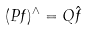Convert formula to latex. <formula><loc_0><loc_0><loc_500><loc_500>( P f ) ^ { \wedge } = Q \hat { f }</formula> 